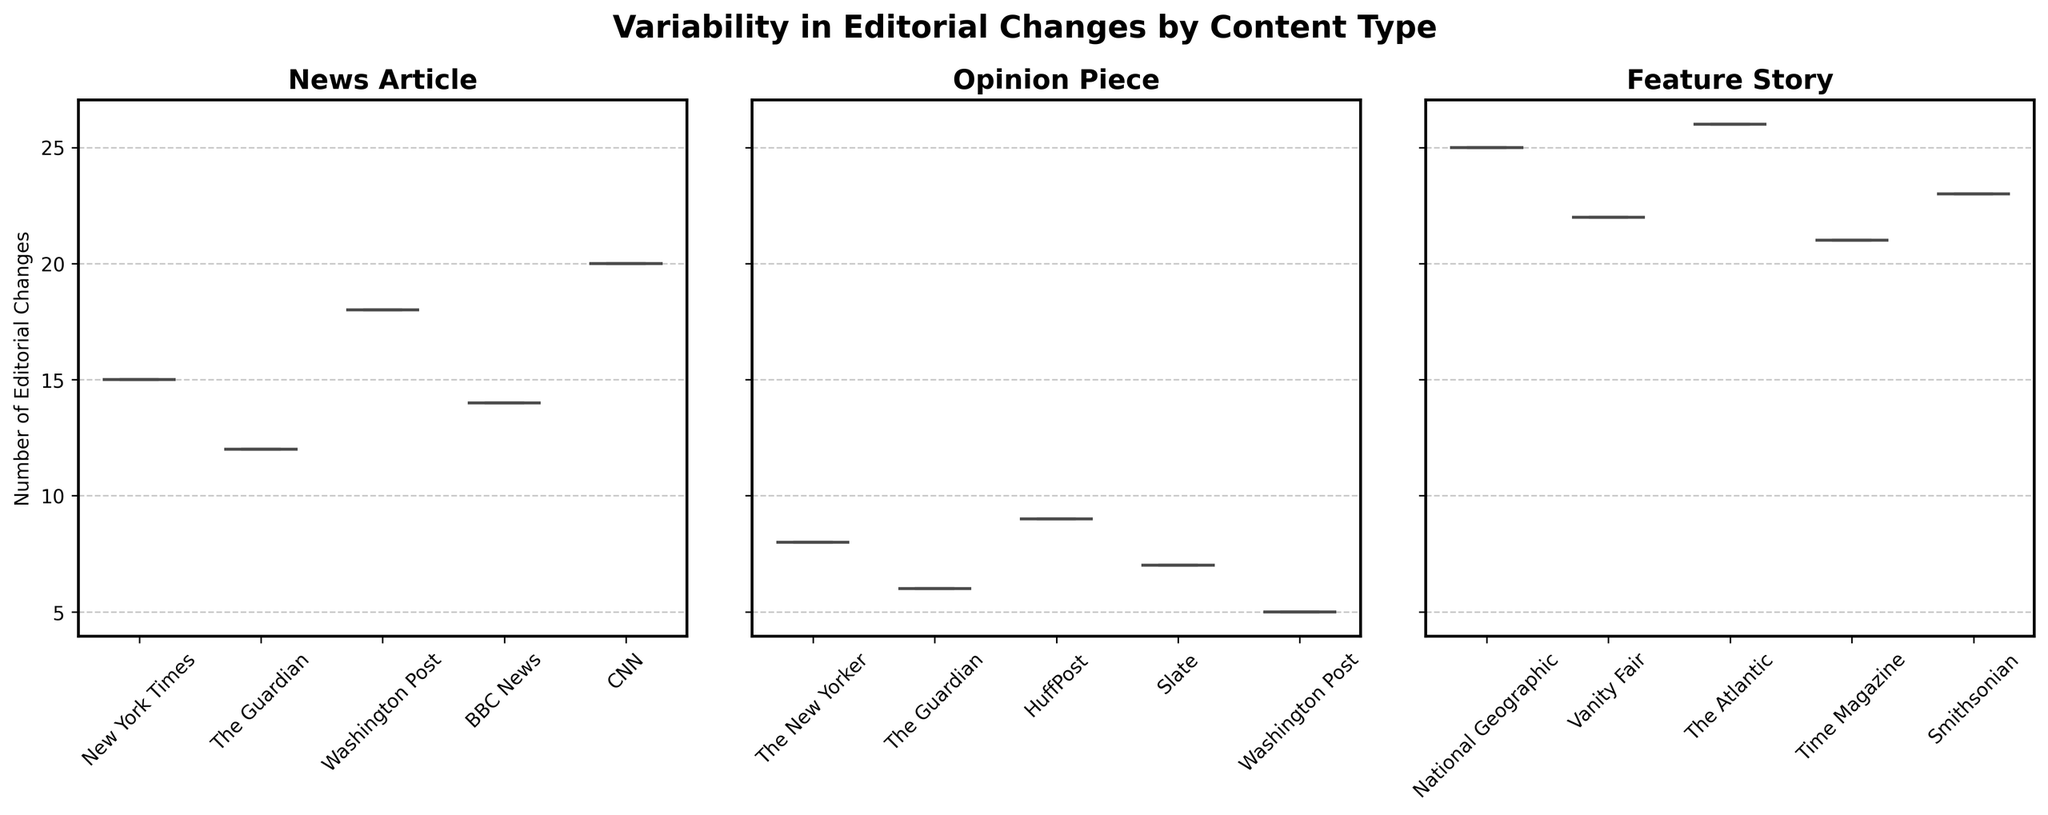What is the title of the figure? The title of the figure is written at the top of the figure in bold, large font. It reads "Variability in Editorial Changes by Content Type."
Answer: Variability in Editorial Changes by Content Type What types of content are compared in the figure? The figure's three subplots are titled according to the content types, which are "News Article," "Opinion Piece," and "Feature Story."
Answer: News Article, Opinion Piece, Feature Story Which content type shows the least variability in editorial changes? Observing the spread of the values in each box plot, the "Opinion Piece" subplot has the smallest interquartile range (IQR), indicating the least variability in editorial changes.
Answer: Opinion Piece How many entities are compared in the News Article plot? By counting the labels on the x-axis of the "News Article" subplot, we see there are five entities: New York Times, The Guardian, Washington Post, BBC News, and CNN.
Answer: 5 Which entity among the Feature Stories has the highest number of editorial changes? By looking at the topmost whisker or point in the "Feature Story" subplot, "The Atlantic" shows the highest number of 26 editorial changes.
Answer: The Atlantic Which News Article entity has the median number of editorial changes? The median is indicated by the line inside the box of the "News Article" subplot. By examining the median lines, "BBC News" has the median number of editorial changes (14).
Answer: BBC News How do the maximum editorial changes in Opinion Pieces compare to Feature Stories? The maximum in "Opinion Piece" is the top whisker (9 changes), while in "Feature Story," it is the top whisker (26 changes). So, Feature Stories have a higher maximum.
Answer: Feature Stories Are the number of editorial changes for CNN and New York Times in News Articles above or below the median for News Articles? The median for News Articles is around 14 changes (BBC News), CNN has 20 and New York Times has 15, both are above this median.
Answer: Above Which entity in Opinion Pieces has the minimum number of editorial changes? In the "Opinion Piece" subplot, the smallest value marked by the bottom of the whisker or outlier for Washington Post is the minimum, showing 5 changes.
Answer: Washington Post 